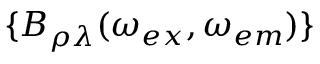<formula> <loc_0><loc_0><loc_500><loc_500>\{ B _ { \rho \lambda } ( \omega _ { e x } , \omega _ { e m } ) \}</formula> 